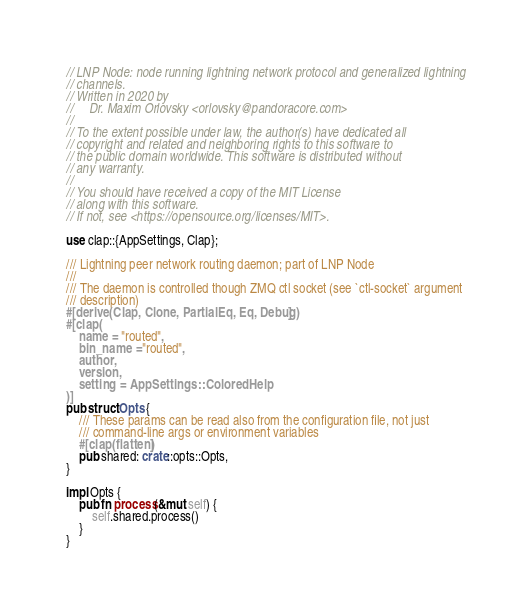Convert code to text. <code><loc_0><loc_0><loc_500><loc_500><_Rust_>// LNP Node: node running lightning network protocol and generalized lightning
// channels.
// Written in 2020 by
//     Dr. Maxim Orlovsky <orlovsky@pandoracore.com>
//
// To the extent possible under law, the author(s) have dedicated all
// copyright and related and neighboring rights to this software to
// the public domain worldwide. This software is distributed without
// any warranty.
//
// You should have received a copy of the MIT License
// along with this software.
// If not, see <https://opensource.org/licenses/MIT>.

use clap::{AppSettings, Clap};

/// Lightning peer network routing daemon; part of LNP Node
///
/// The daemon is controlled though ZMQ ctl socket (see `ctl-socket` argument
/// description)
#[derive(Clap, Clone, PartialEq, Eq, Debug)]
#[clap(
    name = "routed",
    bin_name = "routed",
    author,
    version,
    setting = AppSettings::ColoredHelp
)]
pub struct Opts {
    /// These params can be read also from the configuration file, not just
    /// command-line args or environment variables
    #[clap(flatten)]
    pub shared: crate::opts::Opts,
}

impl Opts {
    pub fn process(&mut self) {
        self.shared.process()
    }
}
</code> 